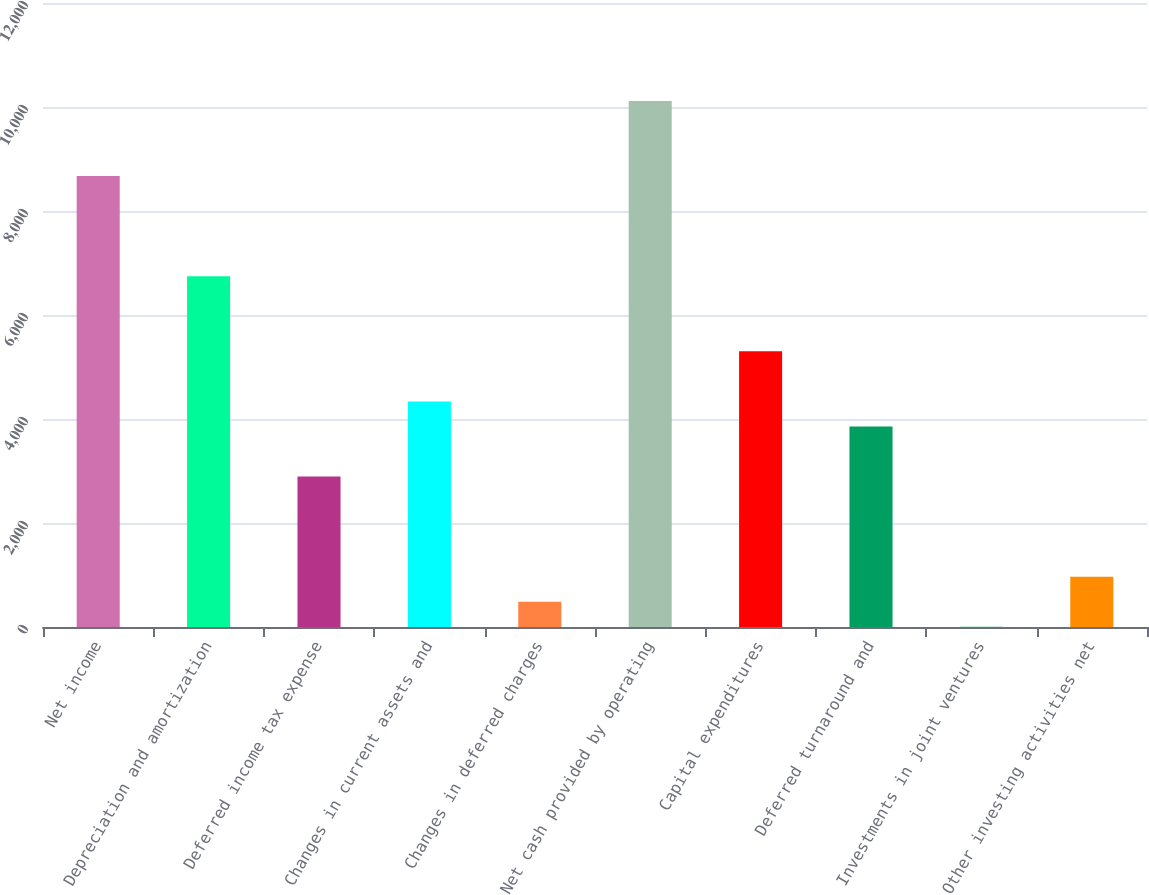Convert chart to OTSL. <chart><loc_0><loc_0><loc_500><loc_500><bar_chart><fcel>Net income<fcel>Depreciation and amortization<fcel>Deferred income tax expense<fcel>Changes in current assets and<fcel>Changes in deferred charges<fcel>Net cash provided by operating<fcel>Capital expenditures<fcel>Deferred turnaround and<fcel>Investments in joint ventures<fcel>Other investing activities net<nl><fcel>8672.8<fcel>6746.4<fcel>2893.6<fcel>4338.4<fcel>485.6<fcel>10117.6<fcel>5301.6<fcel>3856.8<fcel>4<fcel>967.2<nl></chart> 